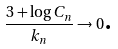Convert formula to latex. <formula><loc_0><loc_0><loc_500><loc_500>\text { } \frac { 3 + \log C _ { n } } { k _ { n } } \rightarrow 0 \text {.}</formula> 